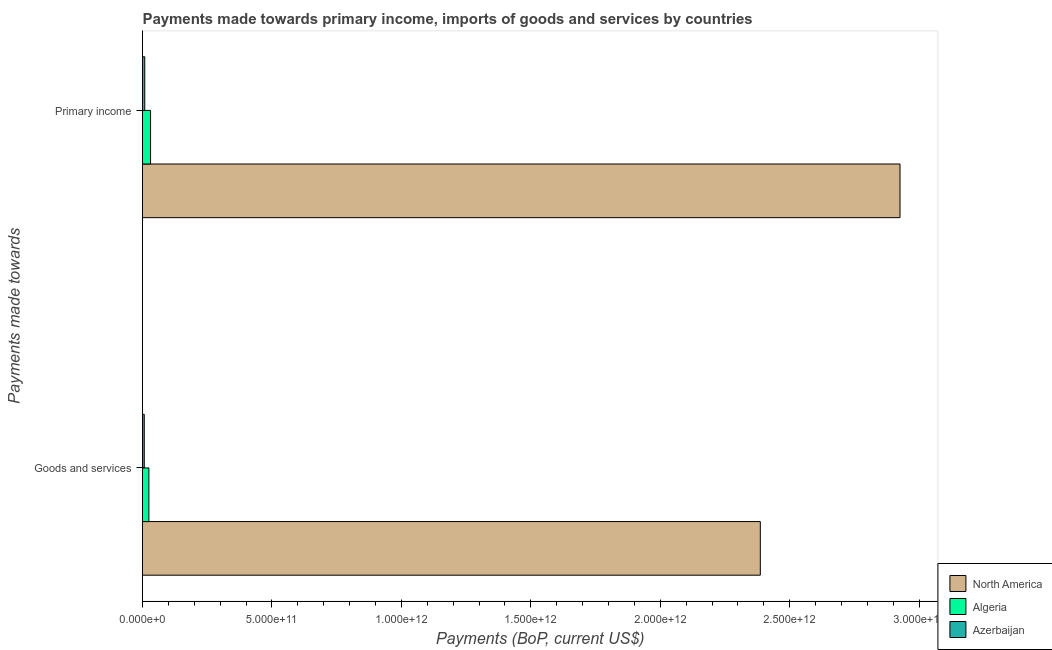How many groups of bars are there?
Offer a terse response. 2. How many bars are there on the 2nd tick from the bottom?
Offer a very short reply. 3. What is the label of the 2nd group of bars from the top?
Keep it short and to the point. Goods and services. What is the payments made towards goods and services in Azerbaijan?
Provide a short and direct response. 6.81e+09. Across all countries, what is the maximum payments made towards goods and services?
Ensure brevity in your answer.  2.39e+12. Across all countries, what is the minimum payments made towards goods and services?
Make the answer very short. 6.81e+09. In which country was the payments made towards goods and services minimum?
Offer a terse response. Azerbaijan. What is the total payments made towards goods and services in the graph?
Your response must be concise. 2.42e+12. What is the difference between the payments made towards primary income in North America and that in Azerbaijan?
Offer a terse response. 2.92e+12. What is the difference between the payments made towards primary income in North America and the payments made towards goods and services in Algeria?
Give a very brief answer. 2.90e+12. What is the average payments made towards goods and services per country?
Your answer should be very brief. 8.06e+11. What is the difference between the payments made towards primary income and payments made towards goods and services in North America?
Keep it short and to the point. 5.40e+11. In how many countries, is the payments made towards primary income greater than 2900000000000 US$?
Your response must be concise. 1. What is the ratio of the payments made towards primary income in North America to that in Azerbaijan?
Provide a succinct answer. 337.98. Is the payments made towards goods and services in Algeria less than that in North America?
Give a very brief answer. Yes. In how many countries, is the payments made towards goods and services greater than the average payments made towards goods and services taken over all countries?
Provide a short and direct response. 1. What does the 1st bar from the top in Goods and services represents?
Keep it short and to the point. Azerbaijan. How many bars are there?
Make the answer very short. 6. What is the difference between two consecutive major ticks on the X-axis?
Make the answer very short. 5.00e+11. Are the values on the major ticks of X-axis written in scientific E-notation?
Ensure brevity in your answer.  Yes. Does the graph contain any zero values?
Give a very brief answer. No. Does the graph contain grids?
Your answer should be compact. No. Where does the legend appear in the graph?
Provide a short and direct response. Bottom right. What is the title of the graph?
Your answer should be compact. Payments made towards primary income, imports of goods and services by countries. What is the label or title of the X-axis?
Provide a succinct answer. Payments (BoP, current US$). What is the label or title of the Y-axis?
Provide a succinct answer. Payments made towards. What is the Payments (BoP, current US$) in North America in Goods and services?
Give a very brief answer. 2.39e+12. What is the Payments (BoP, current US$) of Algeria in Goods and services?
Give a very brief answer. 2.46e+1. What is the Payments (BoP, current US$) of Azerbaijan in Goods and services?
Keep it short and to the point. 6.81e+09. What is the Payments (BoP, current US$) of North America in Primary income?
Your response must be concise. 2.93e+12. What is the Payments (BoP, current US$) in Algeria in Primary income?
Give a very brief answer. 3.12e+1. What is the Payments (BoP, current US$) in Azerbaijan in Primary income?
Offer a very short reply. 8.66e+09. Across all Payments made towards, what is the maximum Payments (BoP, current US$) of North America?
Ensure brevity in your answer.  2.93e+12. Across all Payments made towards, what is the maximum Payments (BoP, current US$) of Algeria?
Your answer should be very brief. 3.12e+1. Across all Payments made towards, what is the maximum Payments (BoP, current US$) of Azerbaijan?
Give a very brief answer. 8.66e+09. Across all Payments made towards, what is the minimum Payments (BoP, current US$) in North America?
Your response must be concise. 2.39e+12. Across all Payments made towards, what is the minimum Payments (BoP, current US$) of Algeria?
Your answer should be very brief. 2.46e+1. Across all Payments made towards, what is the minimum Payments (BoP, current US$) of Azerbaijan?
Offer a very short reply. 6.81e+09. What is the total Payments (BoP, current US$) in North America in the graph?
Offer a terse response. 5.31e+12. What is the total Payments (BoP, current US$) in Algeria in the graph?
Offer a very short reply. 5.58e+1. What is the total Payments (BoP, current US$) of Azerbaijan in the graph?
Provide a short and direct response. 1.55e+1. What is the difference between the Payments (BoP, current US$) in North America in Goods and services and that in Primary income?
Your response must be concise. -5.40e+11. What is the difference between the Payments (BoP, current US$) of Algeria in Goods and services and that in Primary income?
Provide a short and direct response. -6.52e+09. What is the difference between the Payments (BoP, current US$) of Azerbaijan in Goods and services and that in Primary income?
Your answer should be very brief. -1.85e+09. What is the difference between the Payments (BoP, current US$) of North America in Goods and services and the Payments (BoP, current US$) of Algeria in Primary income?
Keep it short and to the point. 2.36e+12. What is the difference between the Payments (BoP, current US$) in North America in Goods and services and the Payments (BoP, current US$) in Azerbaijan in Primary income?
Your answer should be very brief. 2.38e+12. What is the difference between the Payments (BoP, current US$) of Algeria in Goods and services and the Payments (BoP, current US$) of Azerbaijan in Primary income?
Provide a succinct answer. 1.60e+1. What is the average Payments (BoP, current US$) of North America per Payments made towards?
Offer a terse response. 2.66e+12. What is the average Payments (BoP, current US$) of Algeria per Payments made towards?
Your answer should be very brief. 2.79e+1. What is the average Payments (BoP, current US$) of Azerbaijan per Payments made towards?
Your response must be concise. 7.73e+09. What is the difference between the Payments (BoP, current US$) in North America and Payments (BoP, current US$) in Algeria in Goods and services?
Your answer should be very brief. 2.36e+12. What is the difference between the Payments (BoP, current US$) in North America and Payments (BoP, current US$) in Azerbaijan in Goods and services?
Your answer should be compact. 2.38e+12. What is the difference between the Payments (BoP, current US$) in Algeria and Payments (BoP, current US$) in Azerbaijan in Goods and services?
Your response must be concise. 1.78e+1. What is the difference between the Payments (BoP, current US$) of North America and Payments (BoP, current US$) of Algeria in Primary income?
Your answer should be very brief. 2.90e+12. What is the difference between the Payments (BoP, current US$) in North America and Payments (BoP, current US$) in Azerbaijan in Primary income?
Your answer should be compact. 2.92e+12. What is the difference between the Payments (BoP, current US$) in Algeria and Payments (BoP, current US$) in Azerbaijan in Primary income?
Your answer should be compact. 2.25e+1. What is the ratio of the Payments (BoP, current US$) of North America in Goods and services to that in Primary income?
Offer a terse response. 0.82. What is the ratio of the Payments (BoP, current US$) of Algeria in Goods and services to that in Primary income?
Provide a short and direct response. 0.79. What is the ratio of the Payments (BoP, current US$) in Azerbaijan in Goods and services to that in Primary income?
Your answer should be very brief. 0.79. What is the difference between the highest and the second highest Payments (BoP, current US$) of North America?
Provide a succinct answer. 5.40e+11. What is the difference between the highest and the second highest Payments (BoP, current US$) of Algeria?
Provide a short and direct response. 6.52e+09. What is the difference between the highest and the second highest Payments (BoP, current US$) of Azerbaijan?
Make the answer very short. 1.85e+09. What is the difference between the highest and the lowest Payments (BoP, current US$) of North America?
Provide a short and direct response. 5.40e+11. What is the difference between the highest and the lowest Payments (BoP, current US$) of Algeria?
Make the answer very short. 6.52e+09. What is the difference between the highest and the lowest Payments (BoP, current US$) of Azerbaijan?
Your response must be concise. 1.85e+09. 